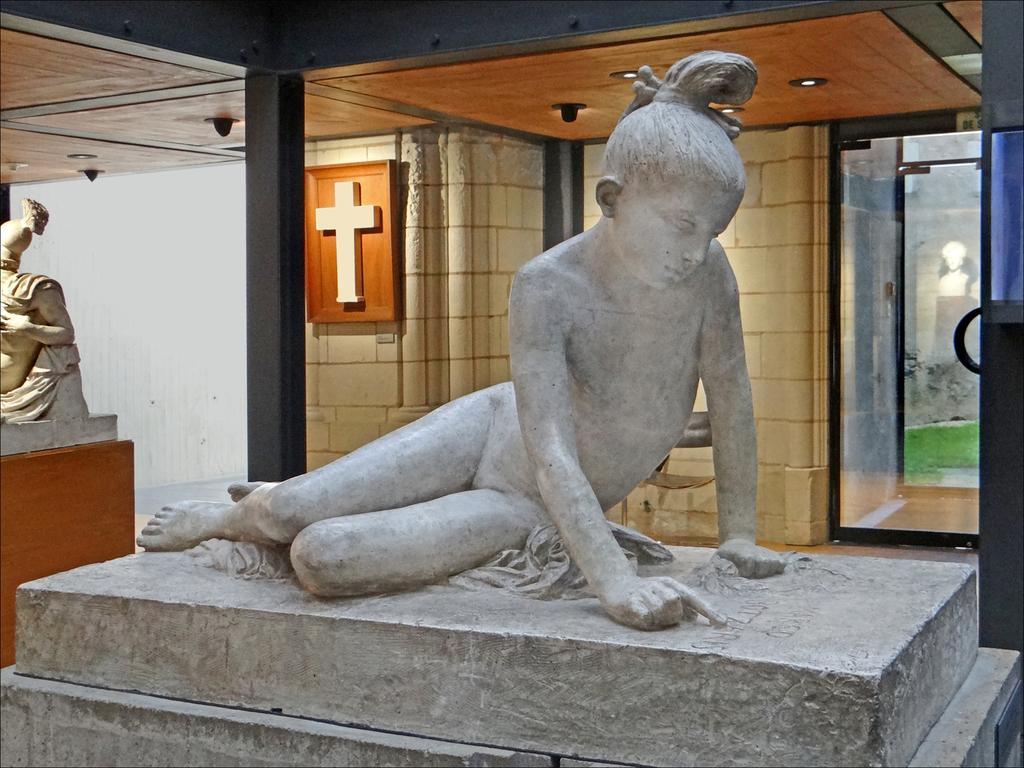Can you describe this image briefly? In this picture we can see statues, pillars, lights, glass, frame on the wall and on this frame we can see a cross and in the background we can see the grass and a statue. 